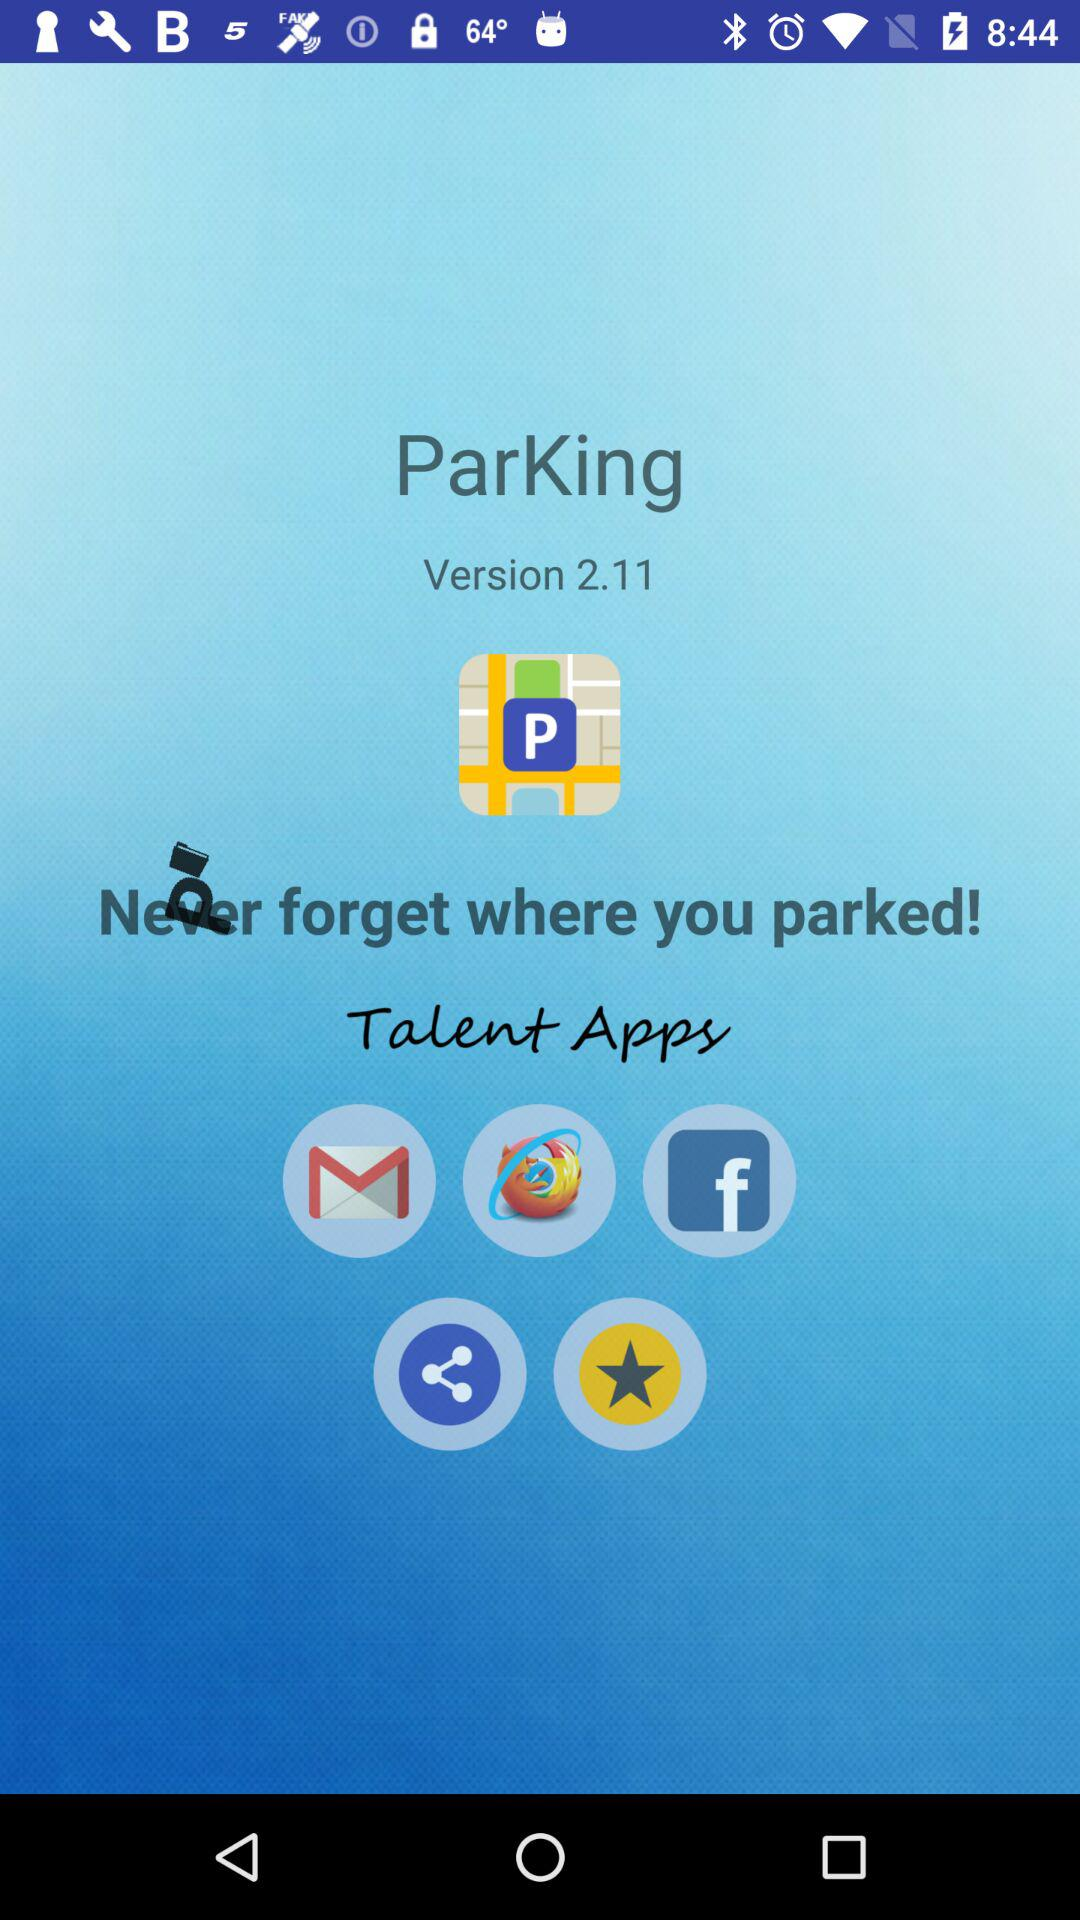What is the version? The version is 2.11. 